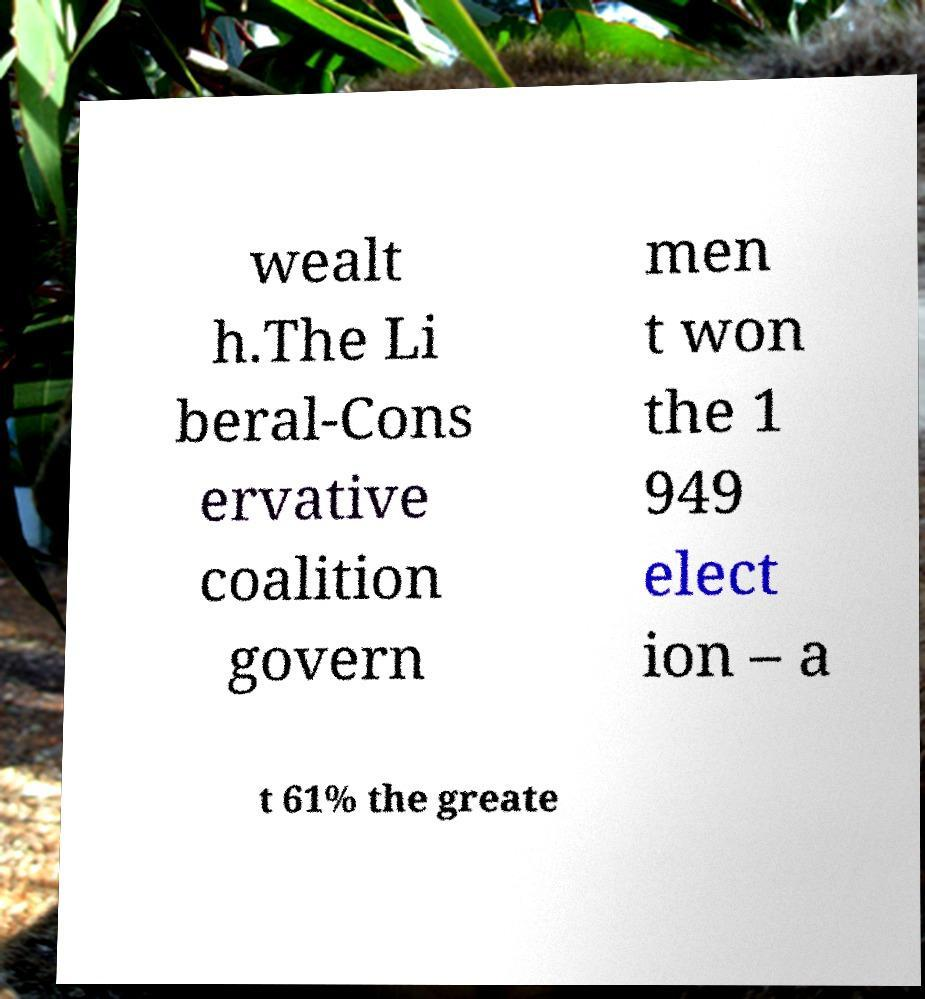Can you accurately transcribe the text from the provided image for me? wealt h.The Li beral-Cons ervative coalition govern men t won the 1 949 elect ion – a t 61% the greate 